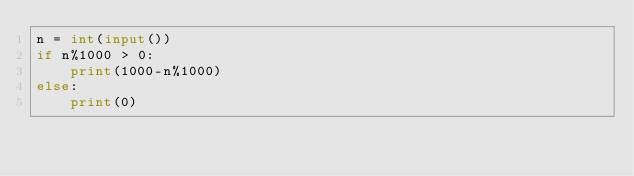<code> <loc_0><loc_0><loc_500><loc_500><_Python_>n = int(input())
if n%1000 > 0:
    print(1000-n%1000)
else:
    print(0)</code> 